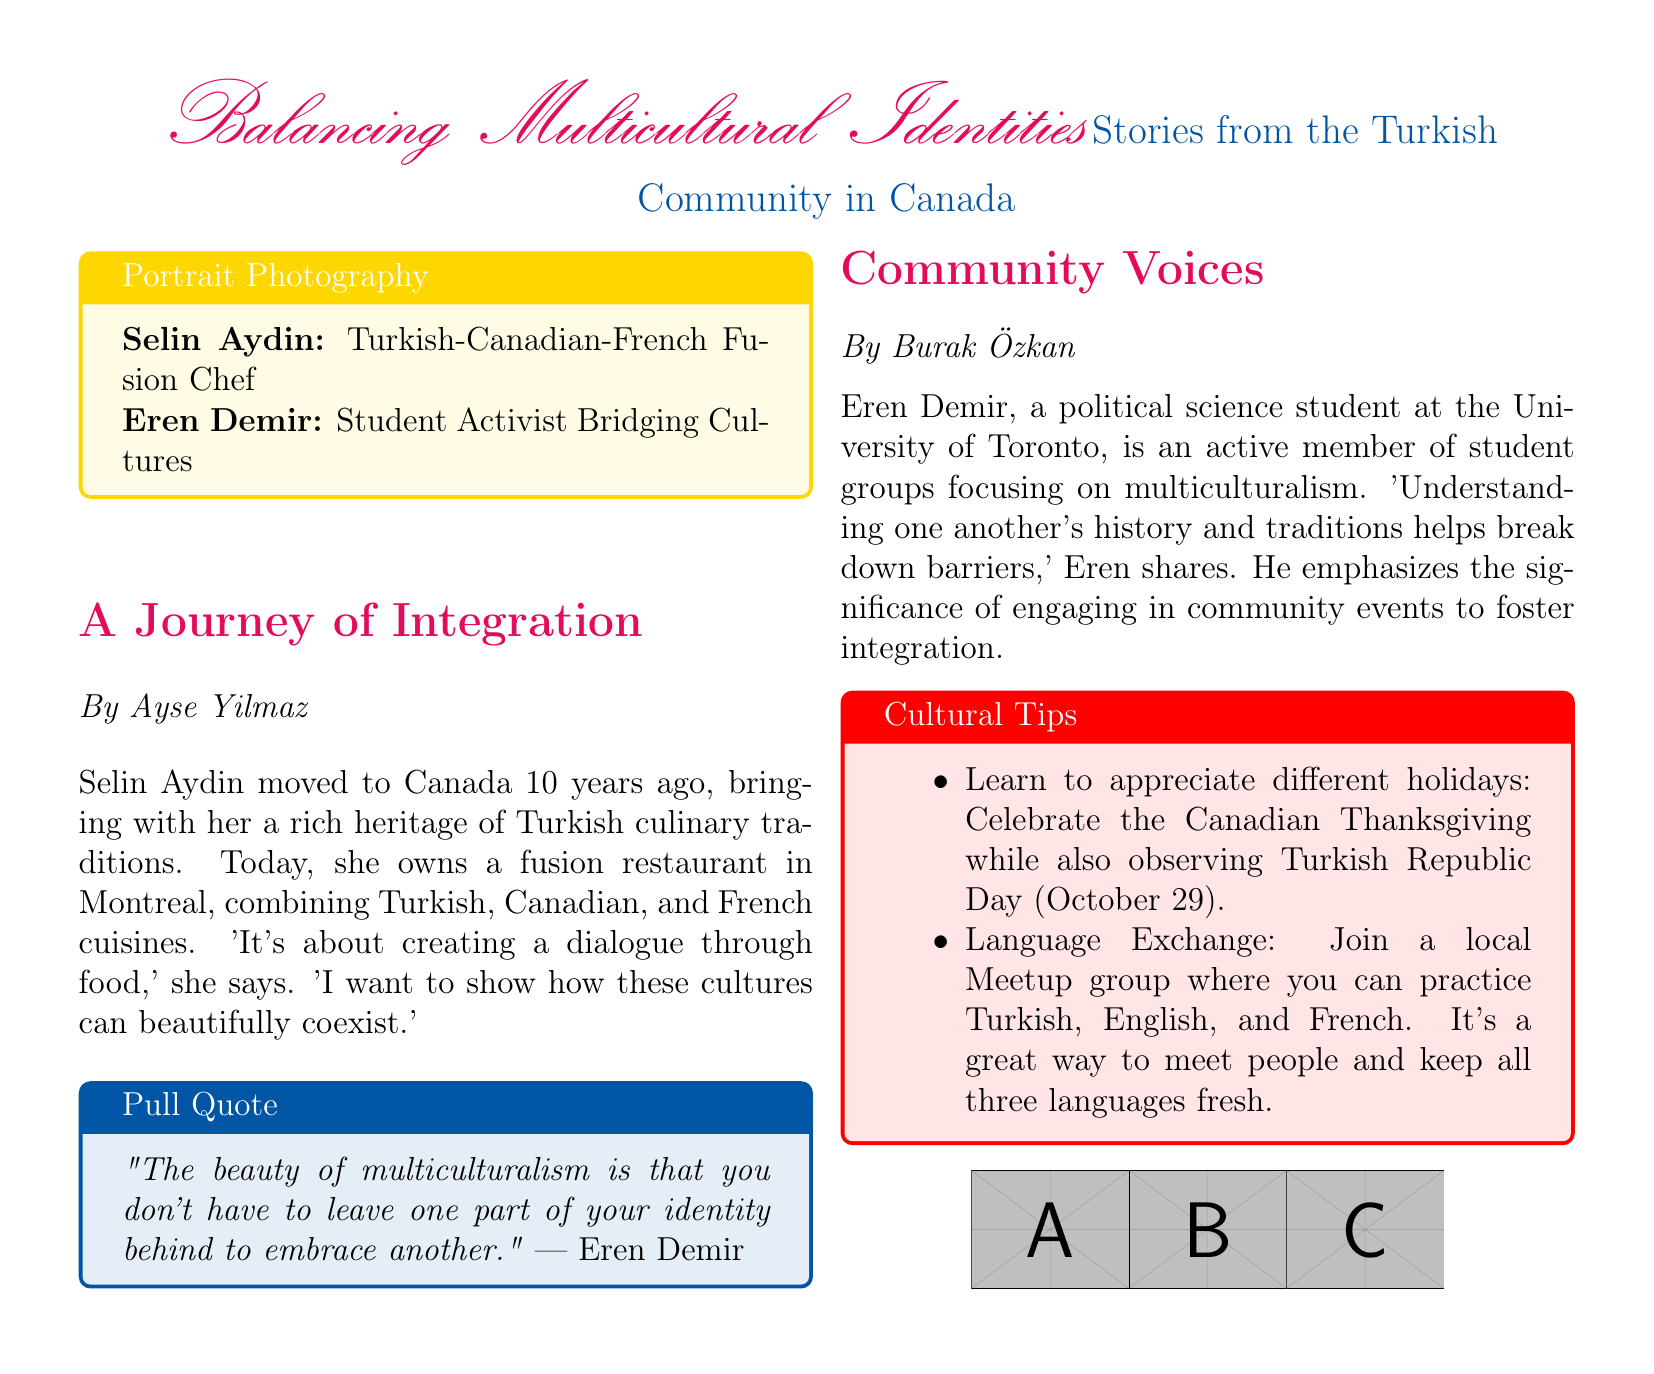What is the name of the Turkish-Canadian-French fusion chef? The document explicitly mentions Selin Aydin as the Turkish-Canadian-French fusion chef.
Answer: Selin Aydin Which city is Selin Aydin's restaurant located in? The document states that Selin Aydin owns a restaurant in Montreal.
Answer: Montreal What is Eren Demir studying at the University of Toronto? The document clearly states that Eren Demir is a political science student.
Answer: Political science What holiday is mentioned alongside Turkish Republic Day for appreciation? According to the cultural tips, Canadian Thanksgiving is mentioned for celebration along with Turkish Republic Day.
Answer: Canadian Thanksgiving What does Eren Demir emphasize as significant for fostering integration? The document states that Eren emphasizes the significance of engaging in community events to foster integration.
Answer: Engaging in community events What is the color theme used for the portrait photography box? The document provides a description of the colors used, and the box for portrait photography is colored gold.
Answer: Gold What is the main theme of the article written by Ayse Yilmaz? The document’s title indicates that the article's theme focuses on a journey of integration.
Answer: A Journey of Integration Which three languages can participants practice in the local Meetup group? The document states that the languages participants can practice include Turkish, English, and French.
Answer: Turkish, English, and French 